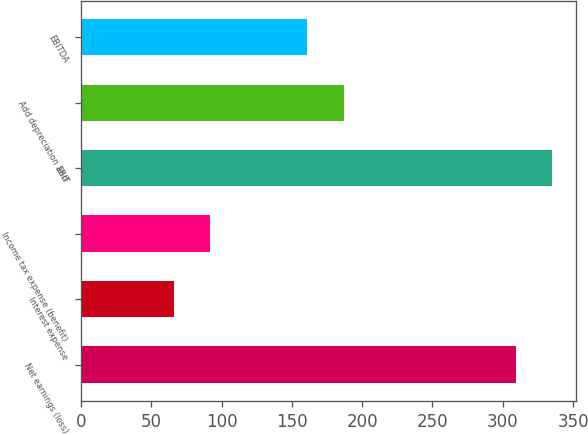Convert chart. <chart><loc_0><loc_0><loc_500><loc_500><bar_chart><fcel>Net earnings (loss)<fcel>Interest expense<fcel>Income tax expense (benefit)<fcel>EBIT<fcel>Add depreciation and<fcel>EBITDA<nl><fcel>309.1<fcel>65.9<fcel>91.91<fcel>335.11<fcel>187.01<fcel>161<nl></chart> 